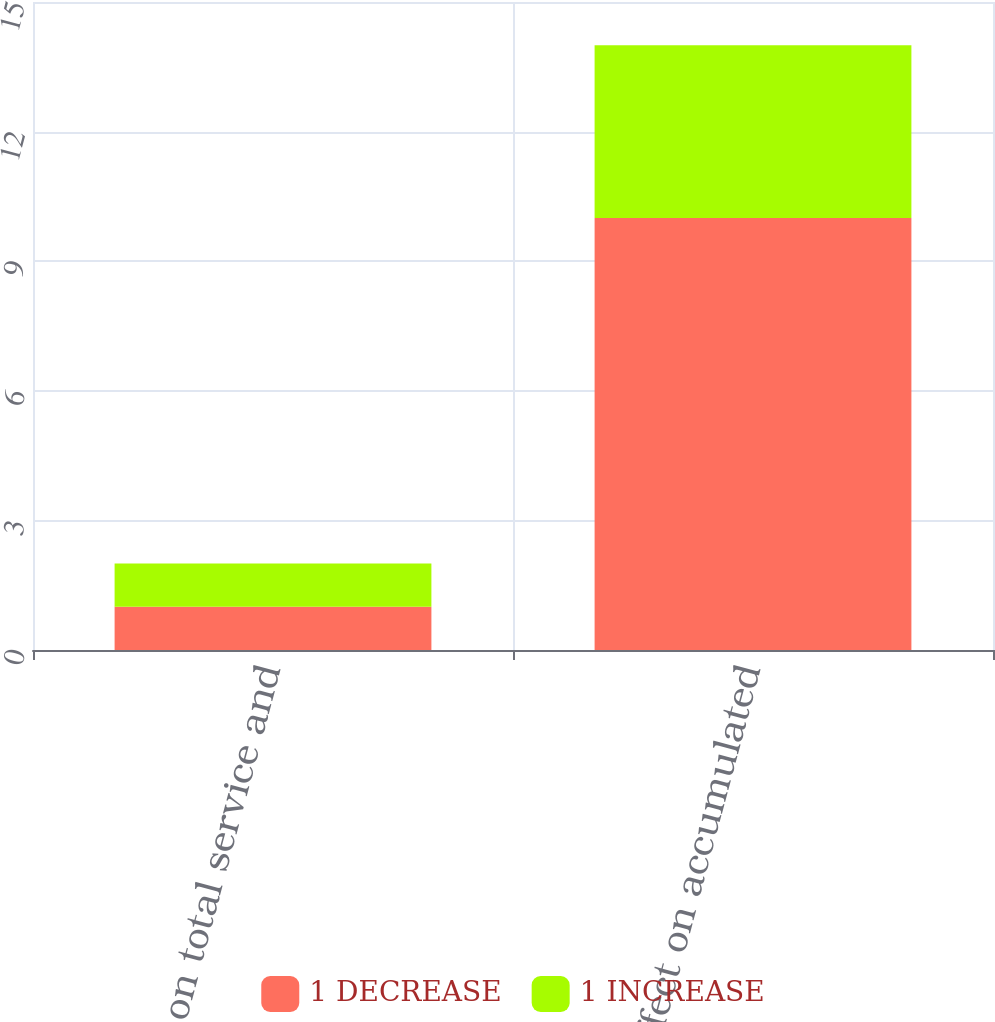<chart> <loc_0><loc_0><loc_500><loc_500><stacked_bar_chart><ecel><fcel>Effect on total service and<fcel>Effect on accumulated<nl><fcel>1 DECREASE<fcel>1<fcel>10<nl><fcel>1 INCREASE<fcel>1<fcel>4<nl></chart> 